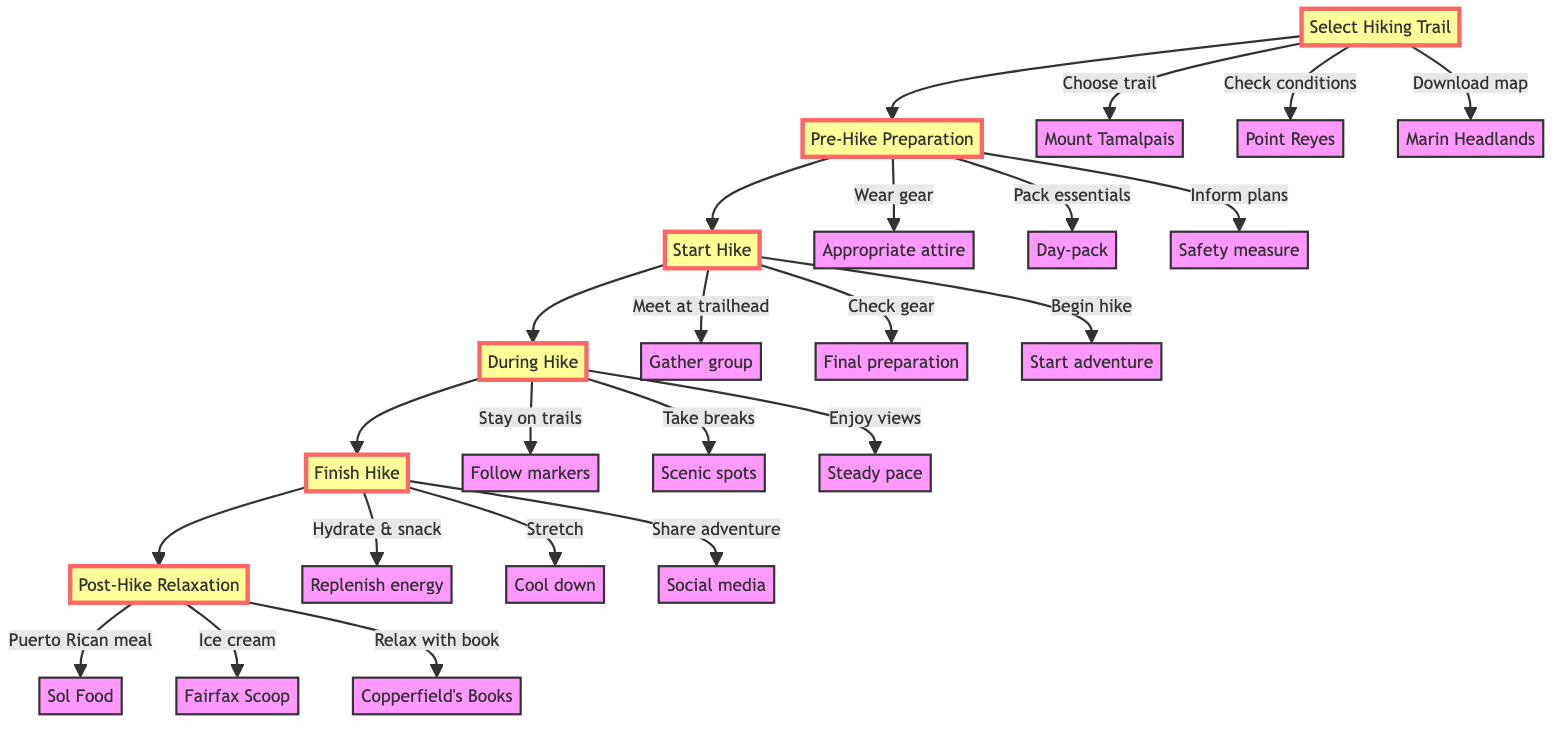What is the topmost step in the diagram? The topmost step is labeled "Post-Hike Relaxation," indicating it is the final stage of the hiking trip process.
Answer: Post-Hike Relaxation How many main steps are in the diagram? The diagram contains six main steps: Select Hiking Trail, Pre-Hike Preparation, Start Hike, During Hike, Finish Hike, and Post-Hike Relaxation.
Answer: Six What are the three options for 'Select Hiking Trail'? The options under 'Select Hiking Trail' include Mount Tamalpais, Point Reyes, and Marin Headlands, as these are the trails listed for selection.
Answer: Mount Tamalpais, Point Reyes, Marin Headlands What must you do before starting the hike? The process before starting the hike involves three tasks: meeting at the trailhead, checking all gear, and beginning the hike, represented under 'Start Hike.'
Answer: Meet at the trailhead, check all gear, begin the hike What is the purpose of the 'During Hike' phase? The 'During Hike' phase provides guidance on what actions to take while hiking, including staying on marked trails, taking breaks, and enjoying the views to maximize the experience.
Answer: Stay on marked trails, take breaks, enjoy the views What action follows 'Finish Hike'? After finishing the hike, the next action is 'Post-Hike Relaxation,' which involves activities to unwind and enjoy the day after hiking.
Answer: Post-Hike Relaxation Which step comes directly before 'During Hike'? The step that comes directly before 'During Hike' is 'Start Hike,' indicating preparation just before engaging in the hike itself.
Answer: Start Hike What should you do during 'Pre-Hike Preparation'? During 'Pre-Hike Preparation,' it's essential to wear appropriate hiking attire and footwear, pack a day-pack with essentials, and inform someone about your hiking plans as a safety measure.
Answer: Wear appropriate attire and footwear, pack essentials, inform someone In which order should the hiking trip steps be completed? The correct order of the hiking trip steps is: Select Hiking Trail, Pre-Hike Preparation, Start Hike, During Hike, Finish Hike, and Post-Hike Relaxation, following the structured flow of the diagram.
Answer: Select Hiking Trail, Pre-Hike Preparation, Start Hike, During Hike, Finish Hike, Post-Hike Relaxation 